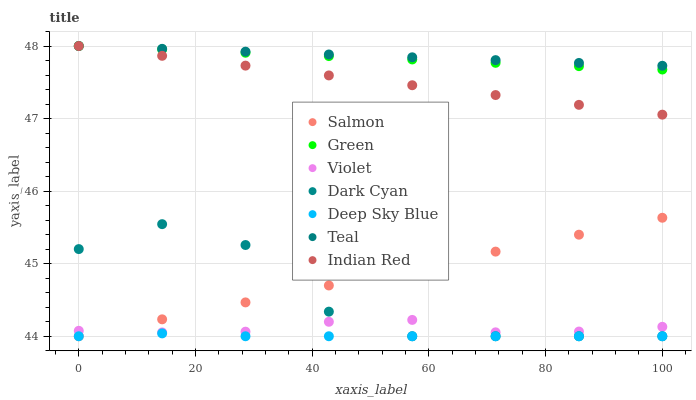Does Deep Sky Blue have the minimum area under the curve?
Answer yes or no. Yes. Does Teal have the maximum area under the curve?
Answer yes or no. Yes. Does Indian Red have the minimum area under the curve?
Answer yes or no. No. Does Indian Red have the maximum area under the curve?
Answer yes or no. No. Is Salmon the smoothest?
Answer yes or no. Yes. Is Dark Cyan the roughest?
Answer yes or no. Yes. Is Indian Red the smoothest?
Answer yes or no. No. Is Indian Red the roughest?
Answer yes or no. No. Does Deep Sky Blue have the lowest value?
Answer yes or no. Yes. Does Indian Red have the lowest value?
Answer yes or no. No. Does Teal have the highest value?
Answer yes or no. Yes. Does Salmon have the highest value?
Answer yes or no. No. Is Violet less than Teal?
Answer yes or no. Yes. Is Teal greater than Salmon?
Answer yes or no. Yes. Does Dark Cyan intersect Violet?
Answer yes or no. Yes. Is Dark Cyan less than Violet?
Answer yes or no. No. Is Dark Cyan greater than Violet?
Answer yes or no. No. Does Violet intersect Teal?
Answer yes or no. No. 